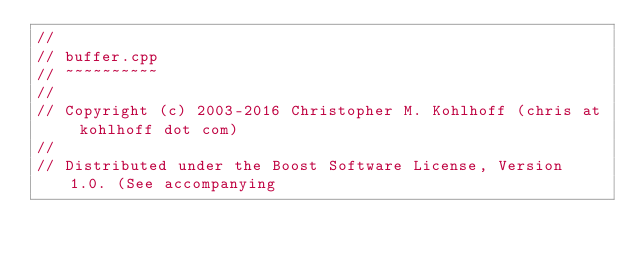<code> <loc_0><loc_0><loc_500><loc_500><_C++_>//
// buffer.cpp
// ~~~~~~~~~~
//
// Copyright (c) 2003-2016 Christopher M. Kohlhoff (chris at kohlhoff dot com)
//
// Distributed under the Boost Software License, Version 1.0. (See accompanying</code> 